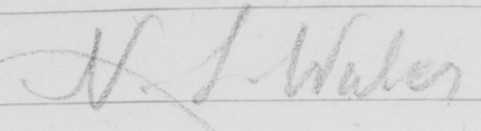Please transcribe the handwritten text in this image. N . S . Wales 